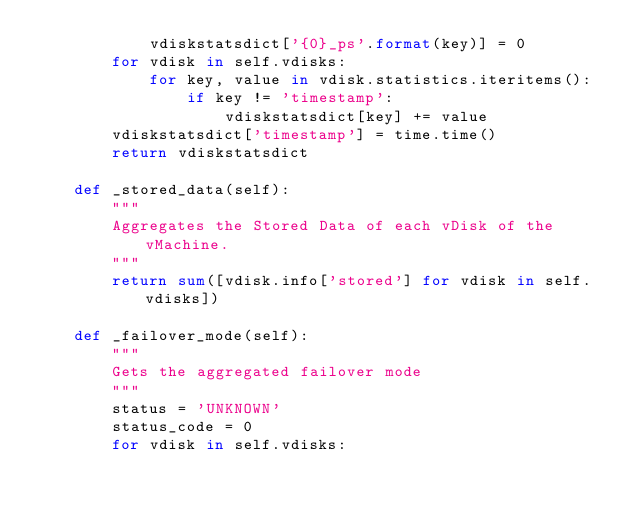<code> <loc_0><loc_0><loc_500><loc_500><_Python_>            vdiskstatsdict['{0}_ps'.format(key)] = 0
        for vdisk in self.vdisks:
            for key, value in vdisk.statistics.iteritems():
                if key != 'timestamp':
                    vdiskstatsdict[key] += value
        vdiskstatsdict['timestamp'] = time.time()
        return vdiskstatsdict

    def _stored_data(self):
        """
        Aggregates the Stored Data of each vDisk of the vMachine.
        """
        return sum([vdisk.info['stored'] for vdisk in self.vdisks])

    def _failover_mode(self):
        """
        Gets the aggregated failover mode
        """
        status = 'UNKNOWN'
        status_code = 0
        for vdisk in self.vdisks:</code> 